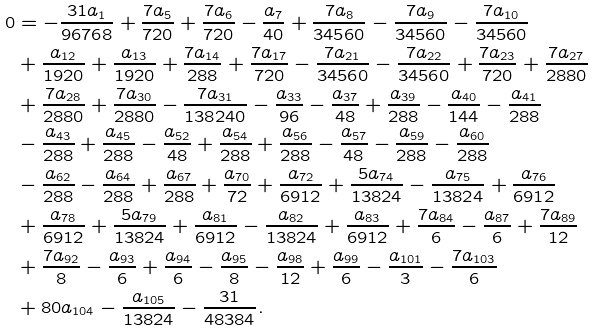<formula> <loc_0><loc_0><loc_500><loc_500>0 & = - \frac { 3 1 a _ { 1 } } { 9 6 7 6 8 } + \frac { 7 a _ { 5 } } { 7 2 0 } + \frac { 7 a _ { 6 } } { 7 2 0 } - \frac { a _ { 7 } } { 4 0 } + \frac { 7 a _ { 8 } } { 3 4 5 6 0 } - \frac { 7 a _ { 9 } } { 3 4 5 6 0 } - \frac { 7 a _ { 1 0 } } { 3 4 5 6 0 } \\ & + \frac { a _ { 1 2 } } { 1 9 2 0 } + \frac { a _ { 1 3 } } { 1 9 2 0 } + \frac { 7 a _ { 1 4 } } { 2 8 8 } + \frac { 7 a _ { 1 7 } } { 7 2 0 } - \frac { 7 a _ { 2 1 } } { 3 4 5 6 0 } - \frac { 7 a _ { 2 2 } } { 3 4 5 6 0 } + \frac { 7 a _ { 2 3 } } { 7 2 0 } + \frac { 7 a _ { 2 7 } } { 2 8 8 0 } \\ & + \frac { 7 a _ { 2 8 } } { 2 8 8 0 } + \frac { 7 a _ { 3 0 } } { 2 8 8 0 } - \frac { 7 a _ { 3 1 } } { 1 3 8 2 4 0 } - \frac { a _ { 3 3 } } { 9 6 } - \frac { a _ { 3 7 } } { 4 8 } + \frac { a _ { 3 9 } } { 2 8 8 } - \frac { a _ { 4 0 } } { 1 4 4 } - \frac { a _ { 4 1 } } { 2 8 8 } \\ & - \frac { a _ { 4 3 } } { 2 8 8 } + \frac { a _ { 4 5 } } { 2 8 8 } - \frac { a _ { 5 2 } } { 4 8 } + \frac { a _ { 5 4 } } { 2 8 8 } + \frac { a _ { 5 6 } } { 2 8 8 } - \frac { a _ { 5 7 } } { 4 8 } - \frac { a _ { 5 9 } } { 2 8 8 } - \frac { a _ { 6 0 } } { 2 8 8 } \\ & - \frac { a _ { 6 2 } } { 2 8 8 } - \frac { a _ { 6 4 } } { 2 8 8 } + \frac { a _ { 6 7 } } { 2 8 8 } + \frac { a _ { 7 0 } } { 7 2 } + \frac { a _ { 7 2 } } { 6 9 1 2 } + \frac { 5 a _ { 7 4 } } { 1 3 8 2 4 } - \frac { a _ { 7 5 } } { 1 3 8 2 4 } + \frac { a _ { 7 6 } } { 6 9 1 2 } \\ & + \frac { a _ { 7 8 } } { 6 9 1 2 } + \frac { 5 a _ { 7 9 } } { 1 3 8 2 4 } + \frac { a _ { 8 1 } } { 6 9 1 2 } - \frac { a _ { 8 2 } } { 1 3 8 2 4 } + \frac { a _ { 8 3 } } { 6 9 1 2 } + \frac { 7 a _ { 8 4 } } { 6 } - \frac { a _ { 8 7 } } { 6 } + \frac { 7 a _ { 8 9 } } { 1 2 } \\ & + \frac { 7 a _ { 9 2 } } { 8 } - \frac { a _ { 9 3 } } { 6 } + \frac { a _ { 9 4 } } { 6 } - \frac { a _ { 9 5 } } { 8 } - \frac { a _ { 9 8 } } { 1 2 } + \frac { a _ { 9 9 } } { 6 } - \frac { a _ { 1 0 1 } } { 3 } - \frac { 7 a _ { 1 0 3 } } { 6 } \\ & + 8 0 a _ { 1 0 4 } - \frac { a _ { 1 0 5 } } { 1 3 8 2 4 } - \frac { 3 1 } { 4 8 3 8 4 } .</formula> 